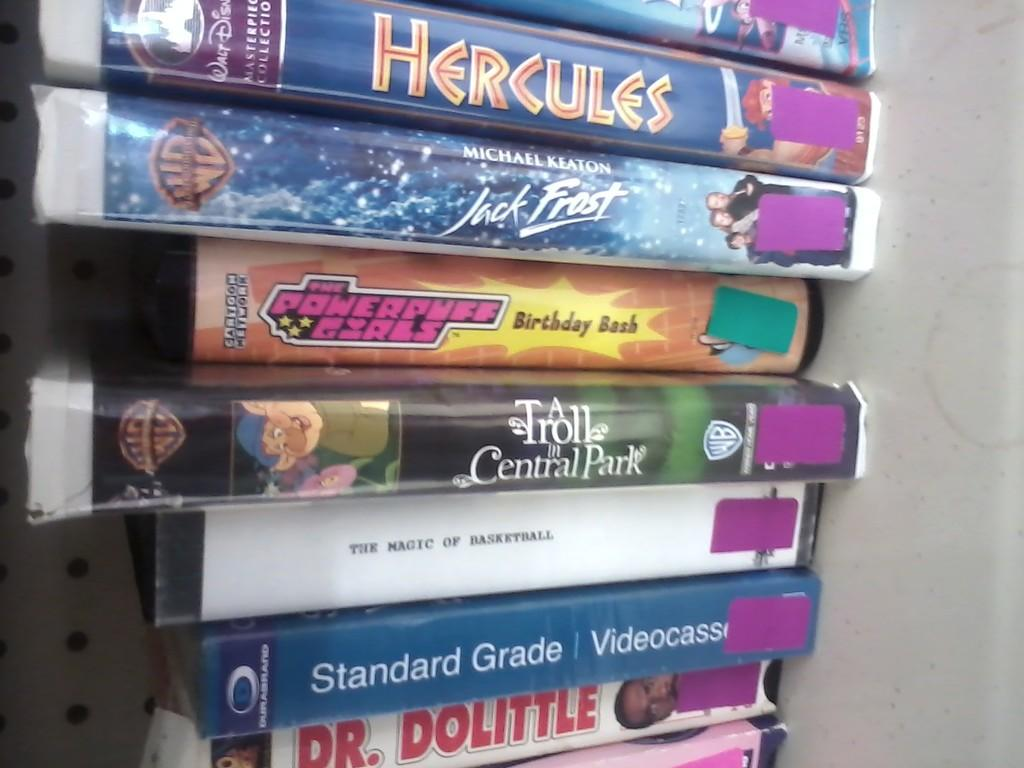<image>
Relay a brief, clear account of the picture shown. lots of DVDS Hercules and jack frost are at the top 